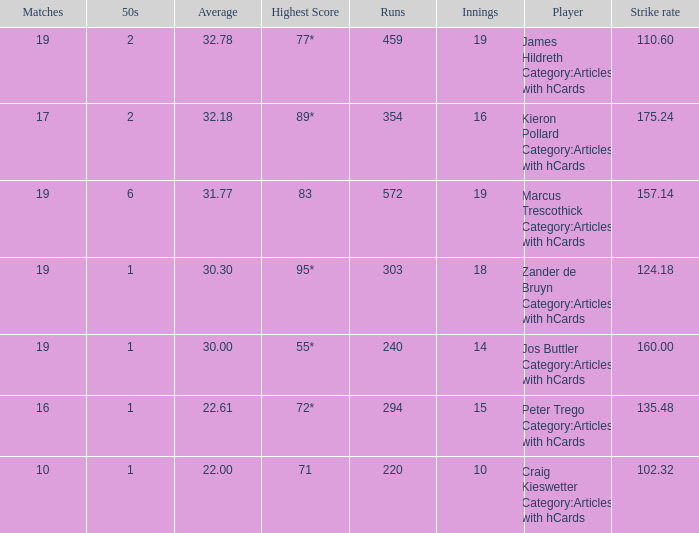What is the strike rate for the player with an average of 32.78? 110.6. 